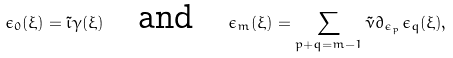<formula> <loc_0><loc_0><loc_500><loc_500>\epsilon _ { 0 } ( \xi ) = \tilde { \iota } \gamma ( \xi ) \quad \text {and} \quad \epsilon _ { m } ( \xi ) = \sum _ { p + q = m - 1 } \tilde { \nu } \partial _ { \epsilon _ { p } } \epsilon _ { q } ( \xi ) ,</formula> 